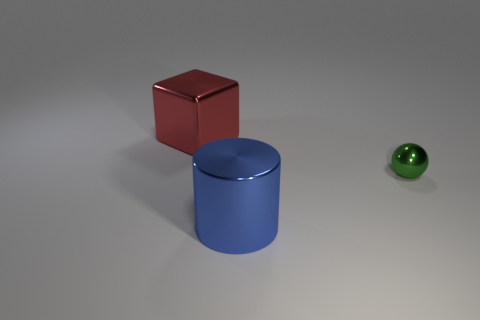What number of cyan balls are there?
Keep it short and to the point. 0. There is a big thing that is made of the same material as the big blue cylinder; what is its color?
Your answer should be very brief. Red. There is a metallic object to the left of the blue shiny cylinder; does it have the same size as the thing in front of the tiny metal thing?
Keep it short and to the point. Yes. How many cylinders are either small red shiny things or blue shiny objects?
Ensure brevity in your answer.  1. Does the object behind the tiny ball have the same material as the blue thing?
Your answer should be very brief. Yes. How many other things are the same size as the red metallic cube?
Provide a short and direct response. 1. How many small objects are shiny spheres or red things?
Provide a succinct answer. 1. Are there more big metal objects behind the cylinder than blue cylinders that are behind the metal ball?
Give a very brief answer. Yes. Is there any other thing that is the same color as the cylinder?
Your answer should be compact. No. Is the number of large blue cylinders left of the small green ball greater than the number of large green matte things?
Make the answer very short. Yes. 